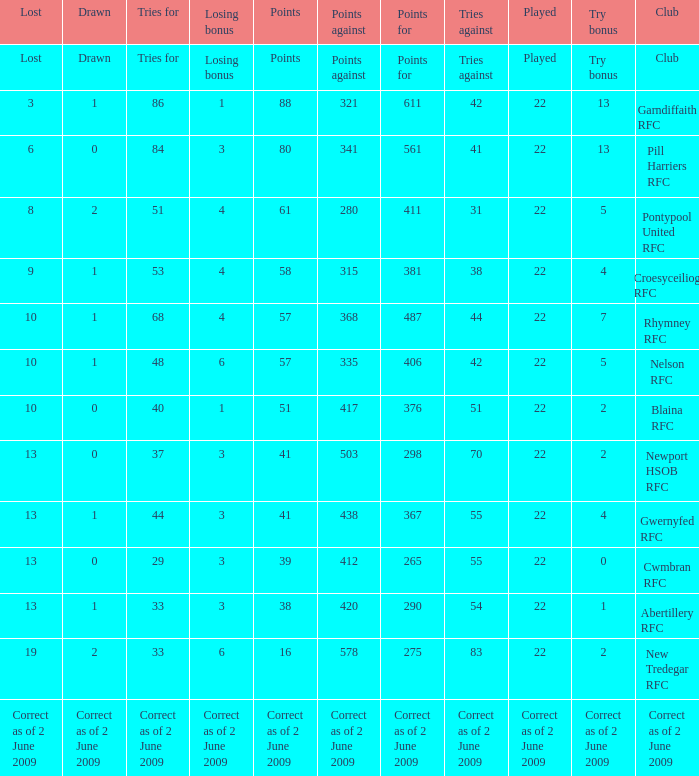How many points against did the club with a losing bonus of 3 and 84 tries have? 341.0. 